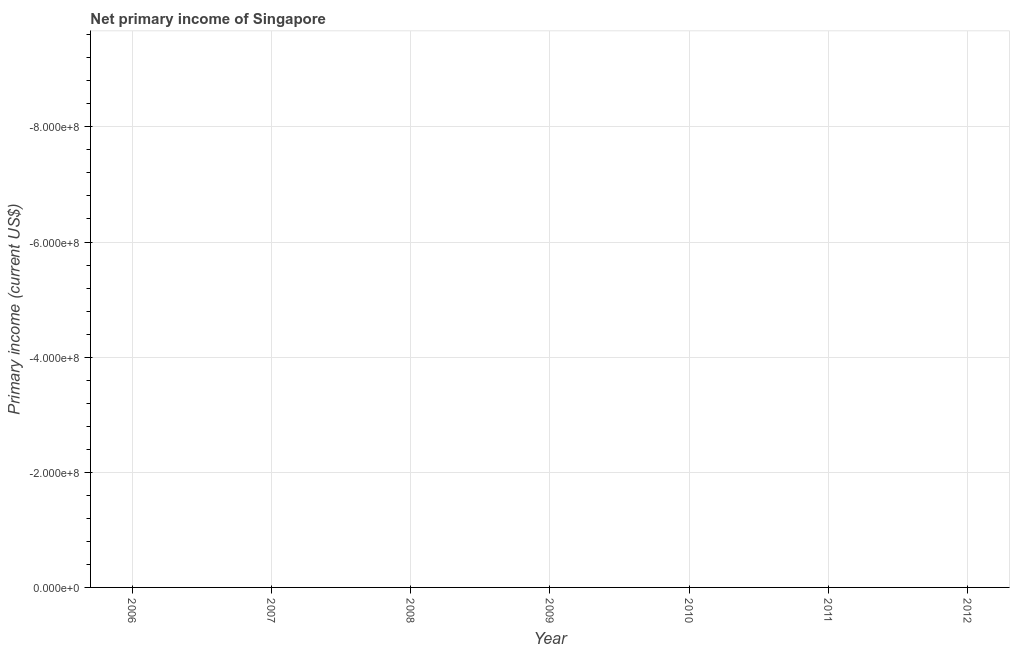What is the amount of primary income in 2011?
Provide a succinct answer. 0. Across all years, what is the minimum amount of primary income?
Keep it short and to the point. 0. What is the sum of the amount of primary income?
Offer a very short reply. 0. What is the median amount of primary income?
Make the answer very short. 0. In how many years, is the amount of primary income greater than -480000000 US$?
Your answer should be compact. 0. Does the amount of primary income monotonically increase over the years?
Provide a short and direct response. No. How many lines are there?
Give a very brief answer. 0. What is the difference between two consecutive major ticks on the Y-axis?
Your response must be concise. 2.00e+08. Does the graph contain any zero values?
Your answer should be very brief. Yes. What is the title of the graph?
Your answer should be very brief. Net primary income of Singapore. What is the label or title of the Y-axis?
Offer a very short reply. Primary income (current US$). What is the Primary income (current US$) in 2006?
Provide a short and direct response. 0. What is the Primary income (current US$) in 2011?
Offer a terse response. 0. 